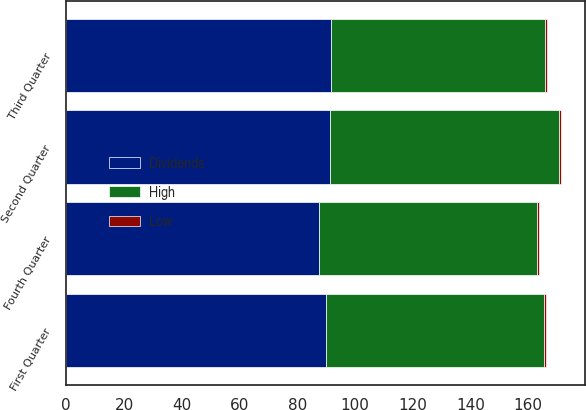Convert chart to OTSL. <chart><loc_0><loc_0><loc_500><loc_500><stacked_bar_chart><ecel><fcel>Fourth Quarter<fcel>Third Quarter<fcel>Second Quarter<fcel>First Quarter<nl><fcel>Dividends<fcel>87.69<fcel>91.68<fcel>91.47<fcel>90.11<nl><fcel>High<fcel>75.4<fcel>74.22<fcel>79.13<fcel>75.32<nl><fcel>Low<fcel>0.7<fcel>0.58<fcel>0.58<fcel>0.58<nl></chart> 